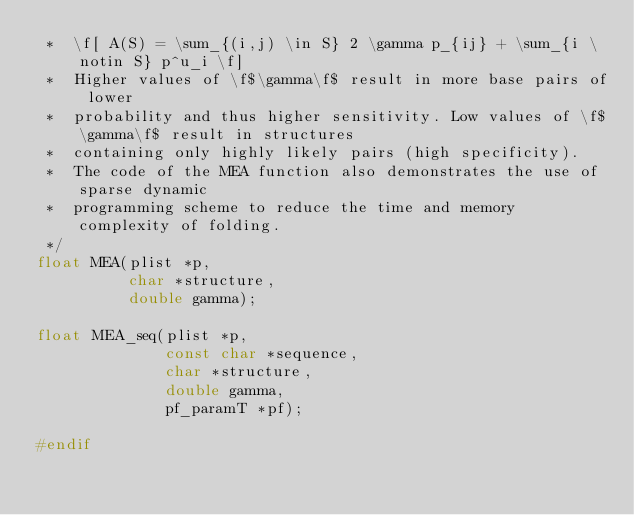Convert code to text. <code><loc_0><loc_0><loc_500><loc_500><_C_> *  \f[ A(S) = \sum_{(i,j) \in S} 2 \gamma p_{ij} + \sum_{i \notin S} p^u_i \f]
 *  Higher values of \f$\gamma\f$ result in more base pairs of lower
 *  probability and thus higher sensitivity. Low values of \f$\gamma\f$ result in structures
 *  containing only highly likely pairs (high specificity).
 *  The code of the MEA function also demonstrates the use of sparse dynamic
 *  programming scheme to reduce the time and memory complexity of folding.
 */
float MEA(plist *p,
          char *structure,
          double gamma);

float MEA_seq(plist *p,
              const char *sequence,
              char *structure,
              double gamma,
              pf_paramT *pf);

#endif
</code> 